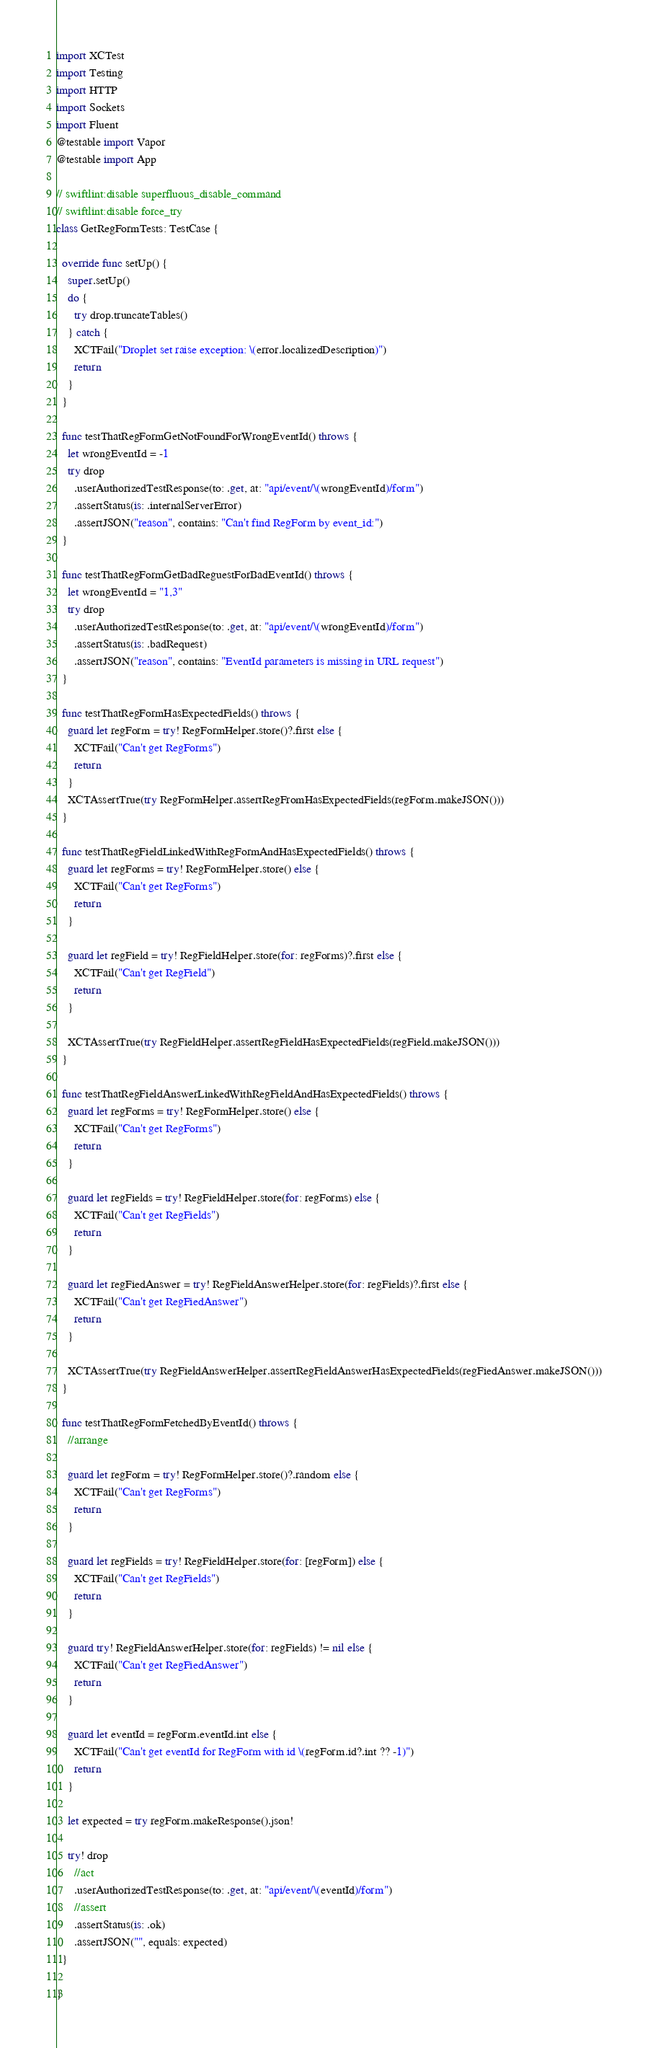<code> <loc_0><loc_0><loc_500><loc_500><_Swift_>import XCTest
import Testing
import HTTP
import Sockets
import Fluent
@testable import Vapor
@testable import App

// swiftlint:disable superfluous_disable_command
// swiftlint:disable force_try
class GetRegFormTests: TestCase {
  
  override func setUp() {
    super.setUp()
    do {
      try drop.truncateTables()
    } catch {
      XCTFail("Droplet set raise exception: \(error.localizedDescription)")
      return
    }
  }
    
  func testThatRegFormGetNotFoundForWrongEventId() throws {
    let wrongEventId = -1
    try drop
      .userAuthorizedTestResponse(to: .get, at: "api/event/\(wrongEventId)/form")
      .assertStatus(is: .internalServerError)
      .assertJSON("reason", contains: "Can't find RegForm by event_id:")
  }
  
  func testThatRegFormGetBadReguestForBadEventId() throws {
    let wrongEventId = "1,3"
    try drop
      .userAuthorizedTestResponse(to: .get, at: "api/event/\(wrongEventId)/form")
      .assertStatus(is: .badRequest)
      .assertJSON("reason", contains: "EventId parameters is missing in URL request")
  }
  
  func testThatRegFormHasExpectedFields() throws {
    guard let regForm = try! RegFormHelper.store()?.first else {
      XCTFail("Can't get RegForms")
      return
    }
    XCTAssertTrue(try RegFormHelper.assertRegFromHasExpectedFields(regForm.makeJSON()))
  }
  
  func testThatRegFieldLinkedWithRegFormAndHasExpectedFields() throws {
    guard let regForms = try! RegFormHelper.store() else {
      XCTFail("Can't get RegForms")
      return
    }
    
    guard let regField = try! RegFieldHelper.store(for: regForms)?.first else {
      XCTFail("Can't get RegField")
      return
    }
    
    XCTAssertTrue(try RegFieldHelper.assertRegFieldHasExpectedFields(regField.makeJSON()))
  }
  
  func testThatRegFieldAnswerLinkedWithRegFieldAndHasExpectedFields() throws {
    guard let regForms = try! RegFormHelper.store() else {
      XCTFail("Can't get RegForms")
      return
    }
    
    guard let regFields = try! RegFieldHelper.store(for: regForms) else {
      XCTFail("Can't get RegFields")
      return
    }
    
    guard let regFiedAnswer = try! RegFieldAnswerHelper.store(for: regFields)?.first else {
      XCTFail("Can't get RegFiedAnswer")
      return
    }
    
    XCTAssertTrue(try RegFieldAnswerHelper.assertRegFieldAnswerHasExpectedFields(regFiedAnswer.makeJSON()))
  }
  
  func testThatRegFormFetchedByEventId() throws {
    //arrange
    
    guard let regForm = try! RegFormHelper.store()?.random else {
      XCTFail("Can't get RegForms")
      return
    }
    
    guard let regFields = try! RegFieldHelper.store(for: [regForm]) else {
      XCTFail("Can't get RegFields")
      return
    }
    
    guard try! RegFieldAnswerHelper.store(for: regFields) != nil else {
      XCTFail("Can't get RegFiedAnswer")
      return
    }
    
    guard let eventId = regForm.eventId.int else {
      XCTFail("Can't get eventId for RegForm with id \(regForm.id?.int ?? -1)")
      return
    }
    
    let expected = try regForm.makeResponse().json!
    
    try! drop
      //act
      .userAuthorizedTestResponse(to: .get, at: "api/event/\(eventId)/form")
      //assert
      .assertStatus(is: .ok)
      .assertJSON("", equals: expected)
  }
  
}
</code> 